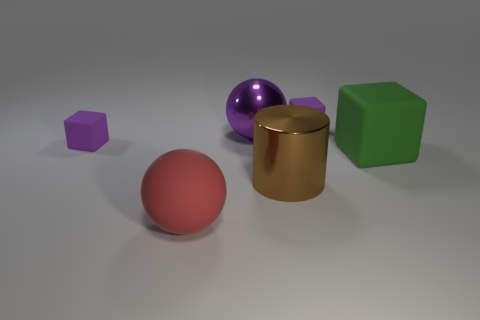Subtract all small purple matte blocks. How many blocks are left? 1 Add 2 green metallic cylinders. How many objects exist? 8 Add 1 green matte cubes. How many green matte cubes exist? 2 Subtract 0 green cylinders. How many objects are left? 6 Subtract all cylinders. How many objects are left? 5 Subtract all green rubber spheres. Subtract all cylinders. How many objects are left? 5 Add 1 green objects. How many green objects are left? 2 